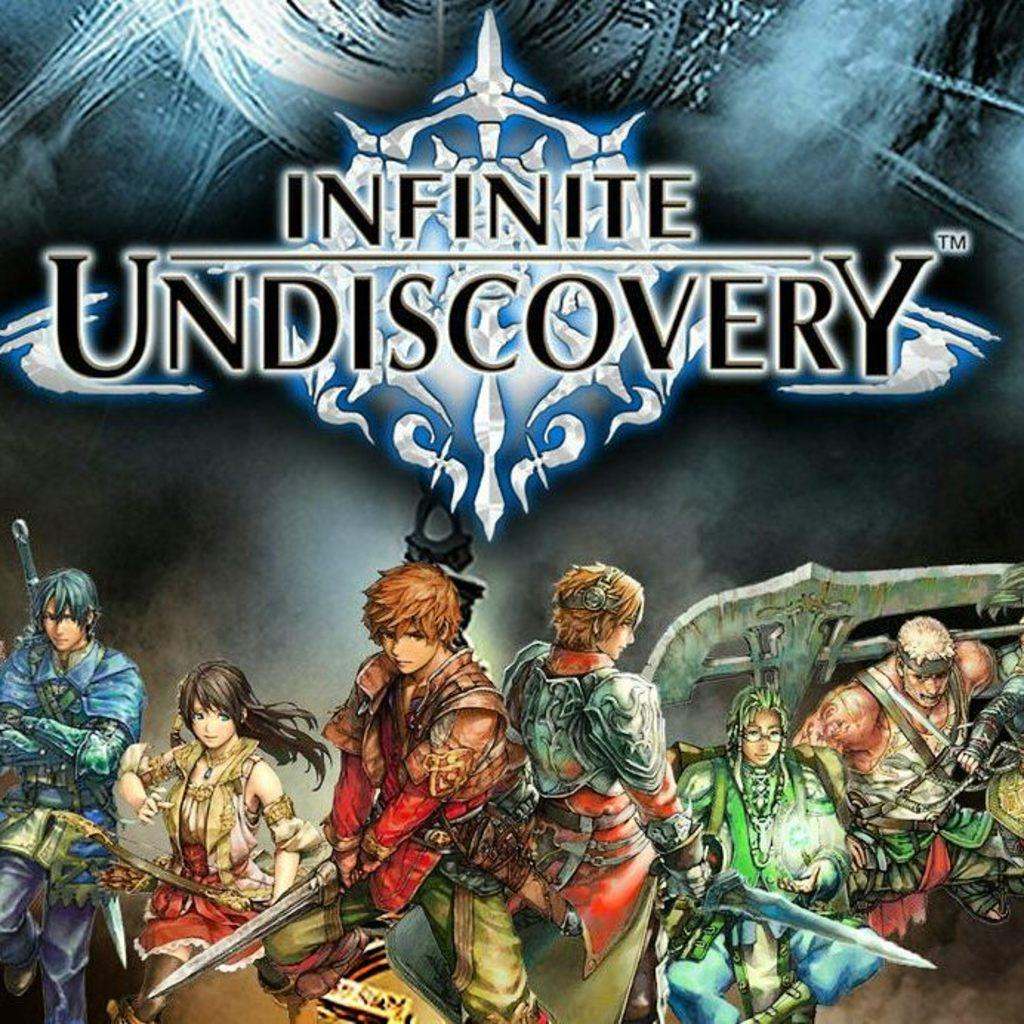<image>
Write a terse but informative summary of the picture. Video game cover for the game Infinite Undiscovery. 